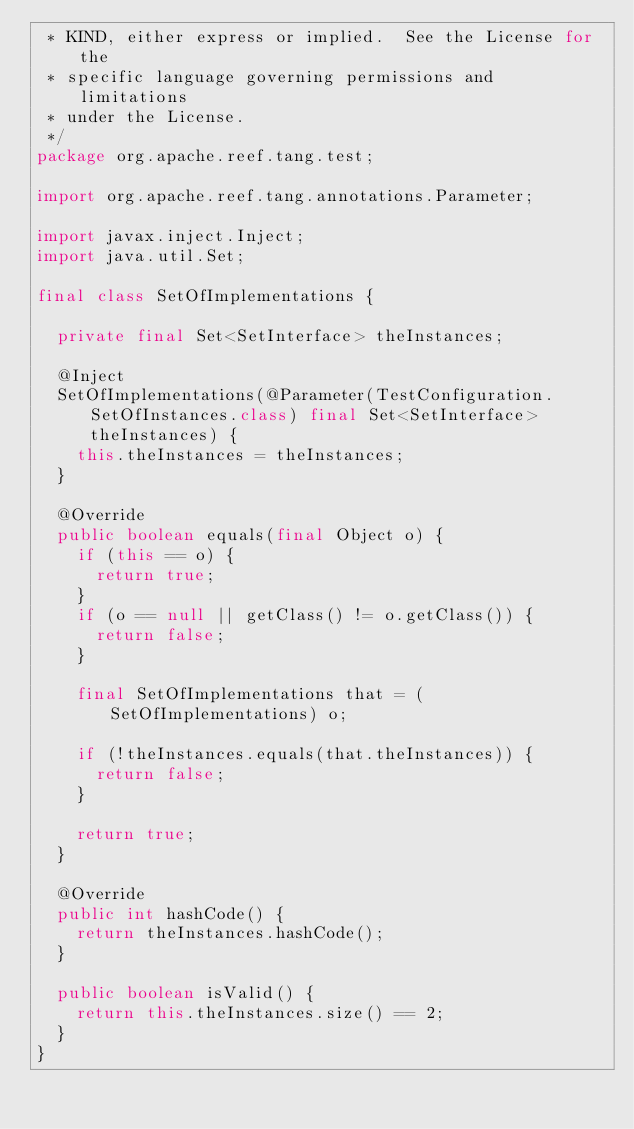Convert code to text. <code><loc_0><loc_0><loc_500><loc_500><_Java_> * KIND, either express or implied.  See the License for the
 * specific language governing permissions and limitations
 * under the License.
 */
package org.apache.reef.tang.test;

import org.apache.reef.tang.annotations.Parameter;

import javax.inject.Inject;
import java.util.Set;

final class SetOfImplementations {

  private final Set<SetInterface> theInstances;

  @Inject
  SetOfImplementations(@Parameter(TestConfiguration.SetOfInstances.class) final Set<SetInterface> theInstances) {
    this.theInstances = theInstances;
  }

  @Override
  public boolean equals(final Object o) {
    if (this == o) {
      return true;
    }
    if (o == null || getClass() != o.getClass()) {
      return false;
    }

    final SetOfImplementations that = (SetOfImplementations) o;

    if (!theInstances.equals(that.theInstances)) {
      return false;
    }

    return true;
  }

  @Override
  public int hashCode() {
    return theInstances.hashCode();
  }

  public boolean isValid() {
    return this.theInstances.size() == 2;
  }
}
</code> 